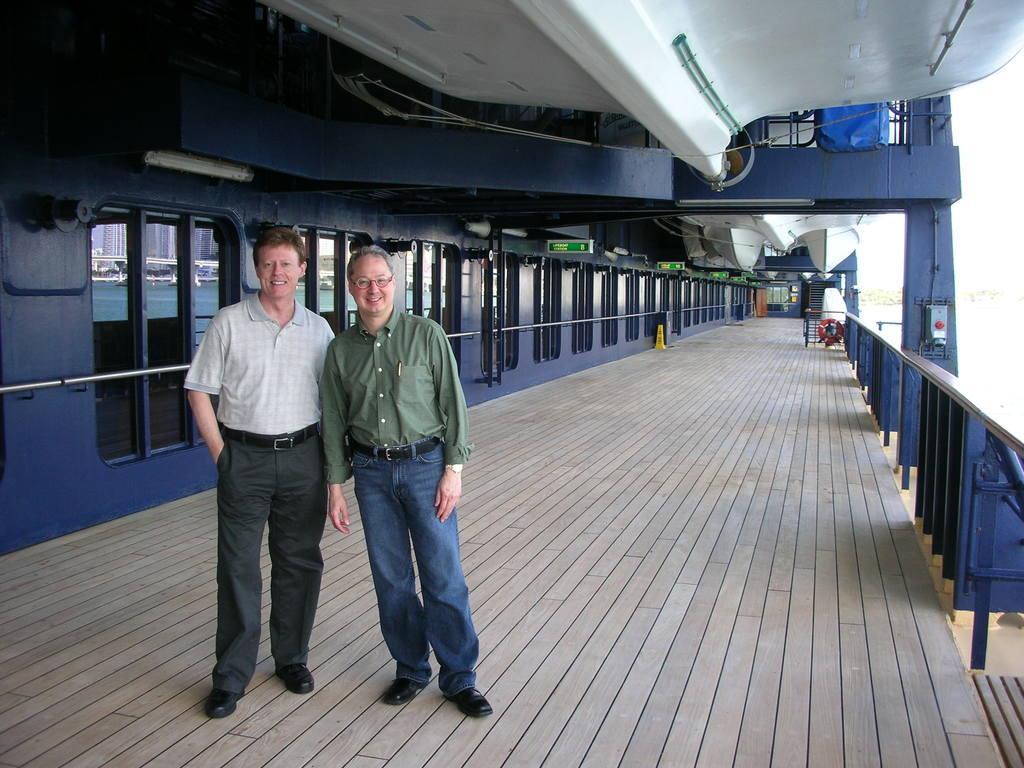Describe this image in one or two sentences. In this image we can see there are two people standing on the floor. On the right side there is a railing and a red color object. And at the left side, it looks like a room and boards attached to it. And there are stairs and yellow color object. 